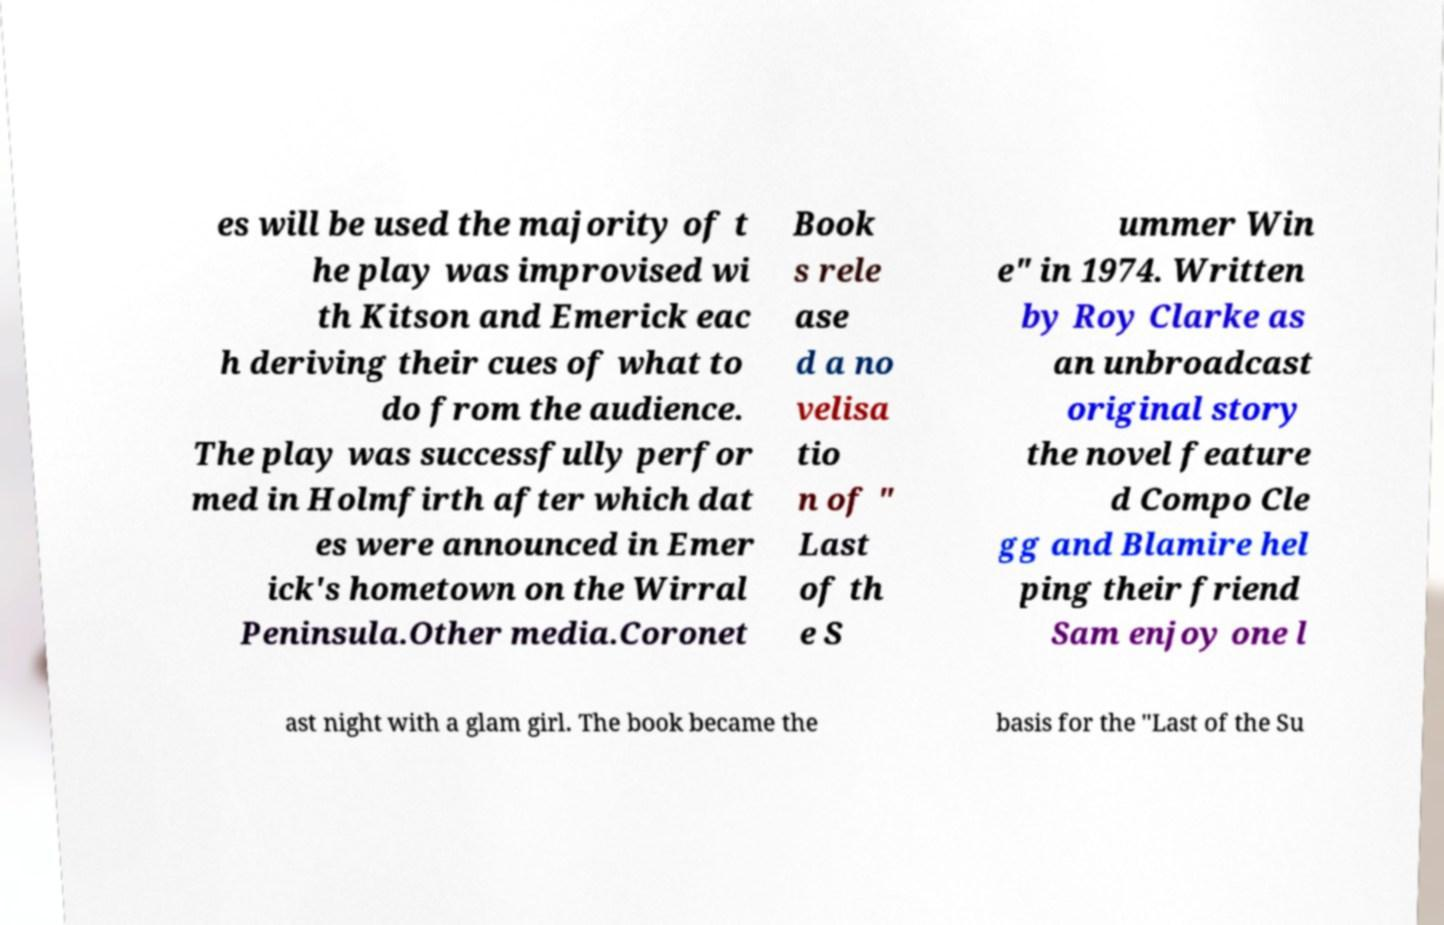Can you accurately transcribe the text from the provided image for me? es will be used the majority of t he play was improvised wi th Kitson and Emerick eac h deriving their cues of what to do from the audience. The play was successfully perfor med in Holmfirth after which dat es were announced in Emer ick's hometown on the Wirral Peninsula.Other media.Coronet Book s rele ase d a no velisa tio n of " Last of th e S ummer Win e" in 1974. Written by Roy Clarke as an unbroadcast original story the novel feature d Compo Cle gg and Blamire hel ping their friend Sam enjoy one l ast night with a glam girl. The book became the basis for the "Last of the Su 